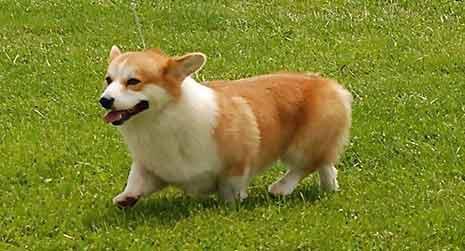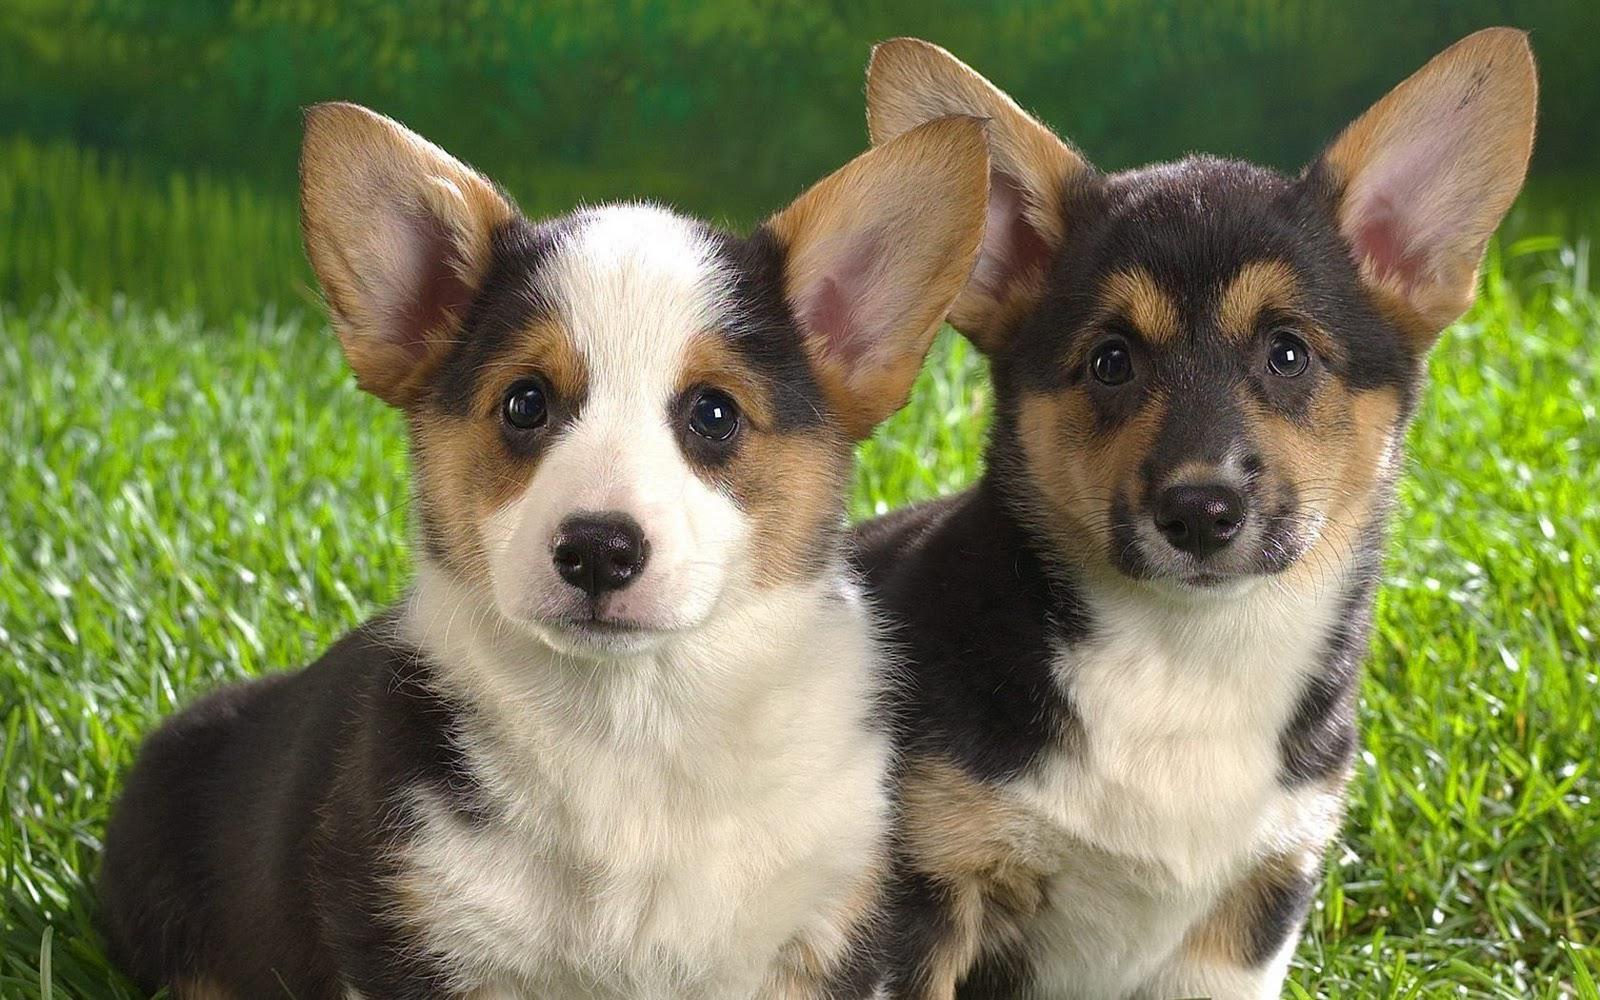The first image is the image on the left, the second image is the image on the right. For the images displayed, is the sentence "A dog is walking on grass with one paw up." factually correct? Answer yes or no. Yes. The first image is the image on the left, the second image is the image on the right. Given the left and right images, does the statement "the dog in the image on the left is in side profile" hold true? Answer yes or no. Yes. 